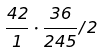<formula> <loc_0><loc_0><loc_500><loc_500>\frac { 4 2 } { 1 } \cdot \frac { 3 6 } { 2 4 5 } / 2</formula> 